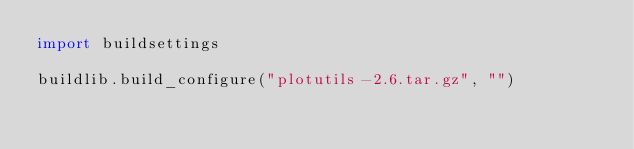Convert code to text. <code><loc_0><loc_0><loc_500><loc_500><_Python_>import buildsettings

buildlib.build_configure("plotutils-2.6.tar.gz", "")</code> 